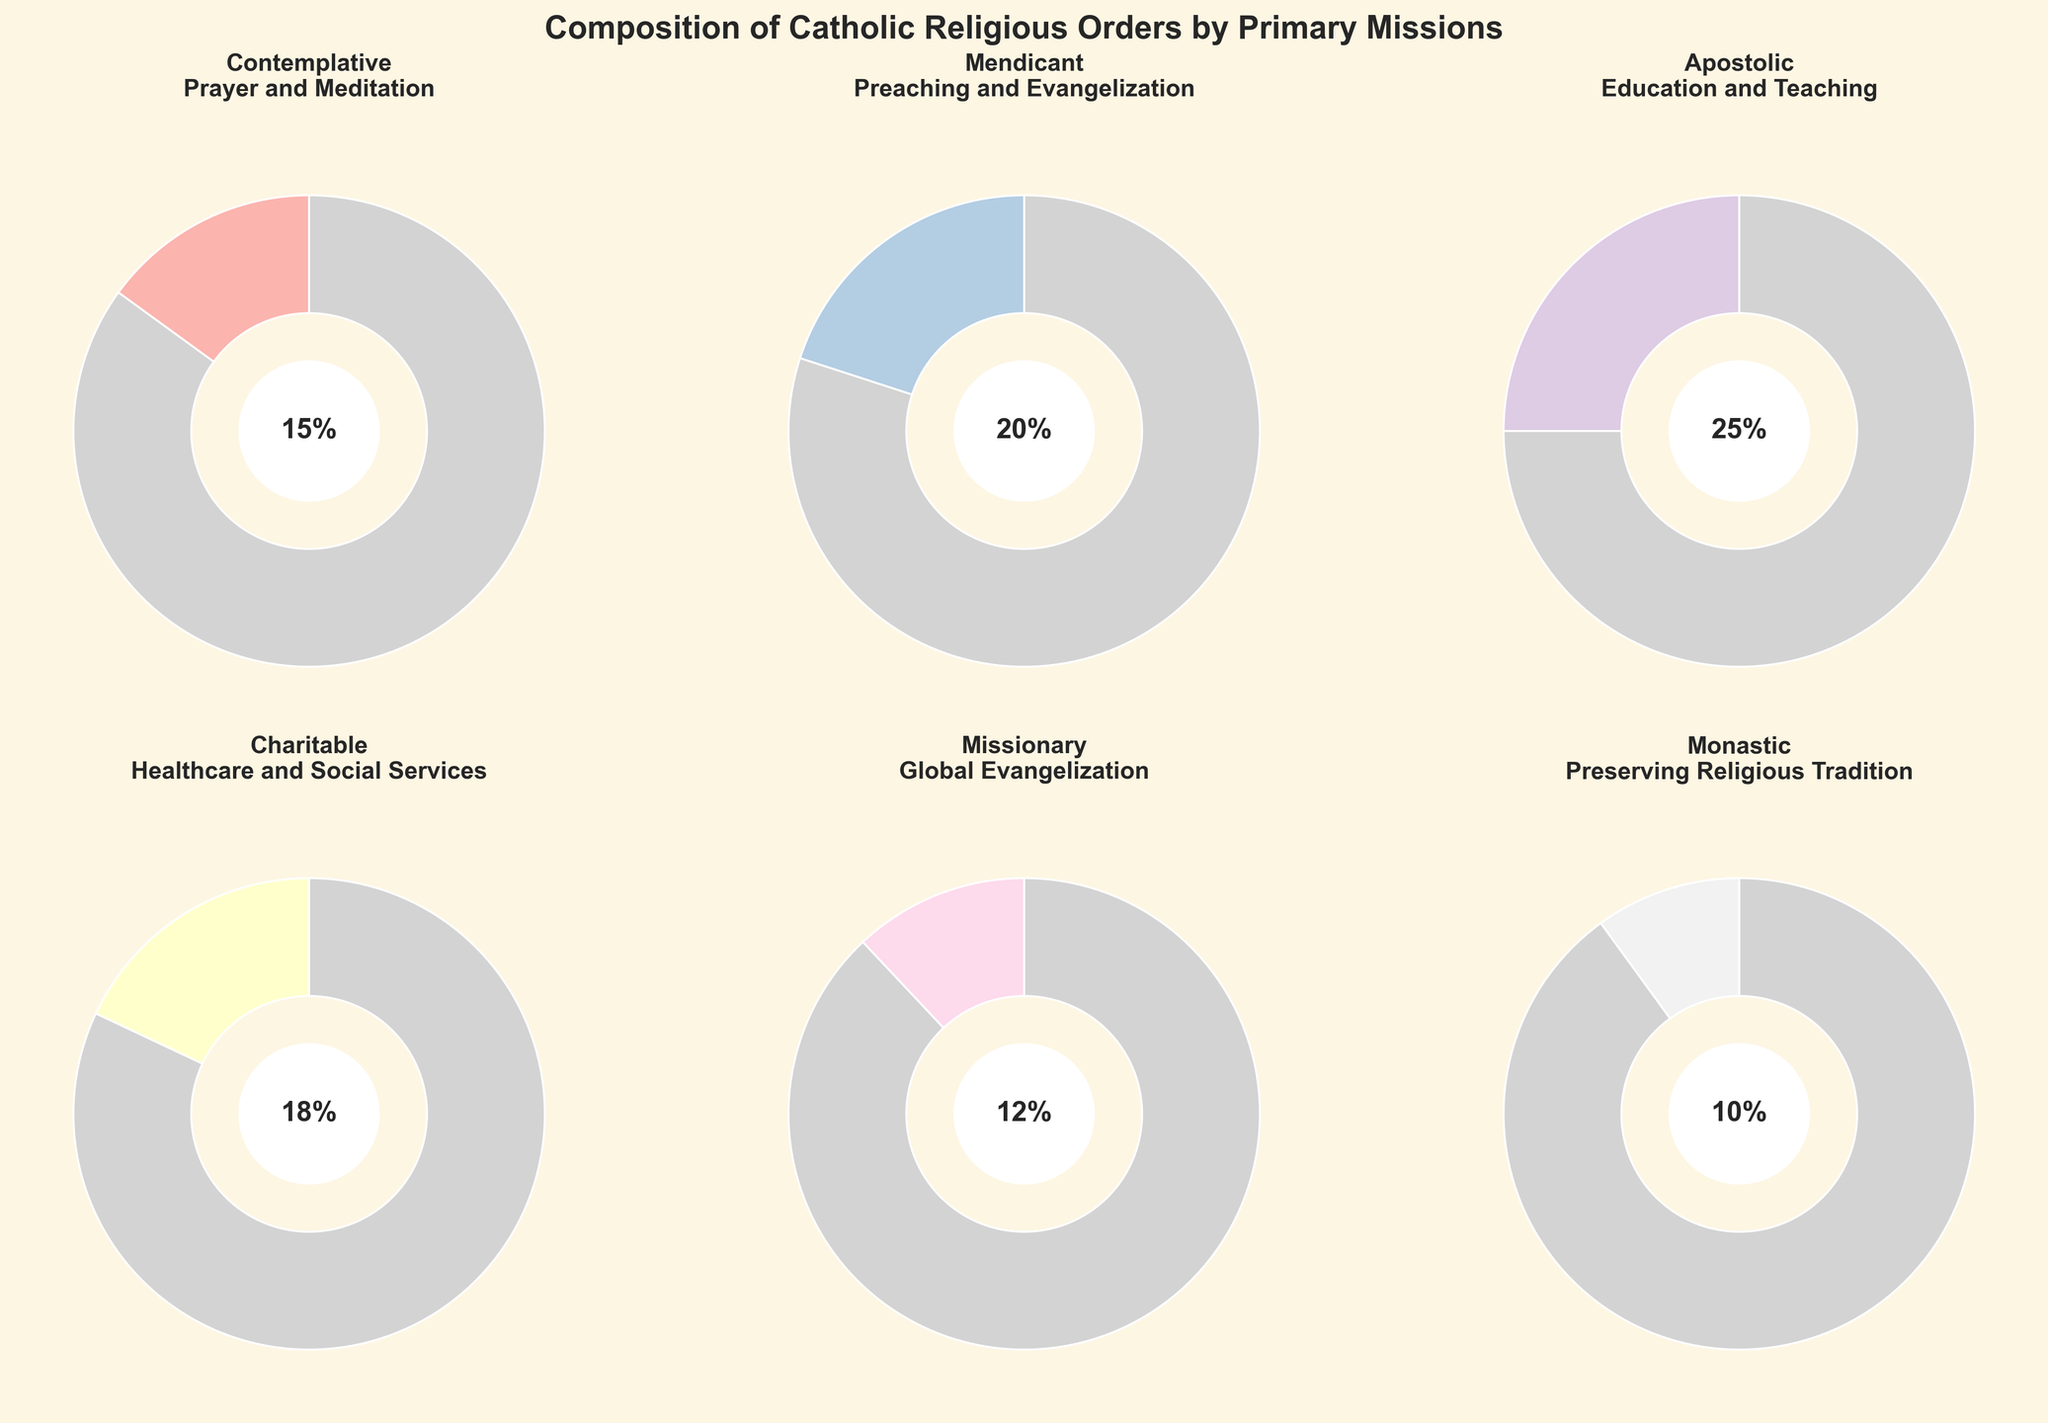What percentage of religious orders are dedicated to preserving religious tradition? Look at the "Monastic" pie chart, which specifies the mission as "Preserving Religious Tradition" and shows a percentage label in the center.
Answer: 10% What is the combined percentage of religious orders focused on healthcare and global evangelization? Sum the percentages from the "Charitable" and "Missionary" pie charts. Charitable is 18% and Missionary is 12%. So, 18% + 12% = 30%.
Answer: 30% Which mission type has the highest percentage among the religious orders? Identify the pie chart with the largest central percentage label. The "Apostolic" chart has the largest at 25%.
Answer: Apostolic (25%) How much higher is the percentage of apostolic orders compared to monastic orders? Subtract the percentage of "Monastic" from "Apostolic". Apostolic is 25% and Monastic is 10%. So, 25% - 10% = 15%.
Answer: 15% What are the two missions with the smallest percentages, and what are their percentages? Identify the two pie charts with the smallest percentages. "Missionary" and "Monastic" have the smallest percentages at 12% and 10%, respectively.
Answer: Missionary (12%) and Monastic (10%) Which two missions together account for 35% of the religious orders? Look for two pie charts that, when their percentages are added, equal 35%. "Contemplative" is 15% and "Global Evangelization" is 12%. "Contemplative" (15%) + "Preserving Religious Tradition" (20%) = 35%.
Answer: Contemplative and Preaching and Evangelization How many different primary missions are there among the Catholic religious orders? Count the number of distinct pie charts present in the figure.
Answer: 6 What's the difference between the largest and smallest percentage values in the pie charts? Identify the largest percentage, "Apostolic" at 25%, and the smallest, "Monastic" at 10%, then subtract them. 25% - 10% = 15%.
Answer: 15% Which mission is depicted in a pie chart where the grey section is 75%? The grey section in the pie charts represents the complementary part of the given percentage. The complementary of 25% is 75%. So, the "Apostolic" mission has a 75% grey section since its percentage is 25%.
Answer: Apostolic 